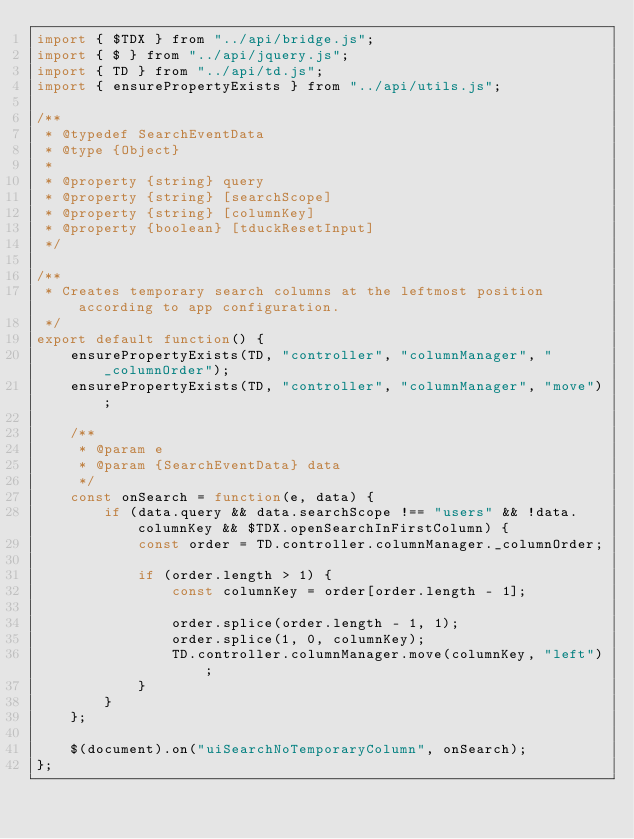Convert code to text. <code><loc_0><loc_0><loc_500><loc_500><_JavaScript_>import { $TDX } from "../api/bridge.js";
import { $ } from "../api/jquery.js";
import { TD } from "../api/td.js";
import { ensurePropertyExists } from "../api/utils.js";

/**
 * @typedef SearchEventData
 * @type {Object}
 *
 * @property {string} query
 * @property {string} [searchScope]
 * @property {string} [columnKey]
 * @property {boolean} [tduckResetInput]
 */

/**
 * Creates temporary search columns at the leftmost position according to app configuration.
 */
export default function() {
	ensurePropertyExists(TD, "controller", "columnManager", "_columnOrder");
	ensurePropertyExists(TD, "controller", "columnManager", "move");
	
	/**
	 * @param e
	 * @param {SearchEventData} data
	 */
	const onSearch = function(e, data) {
		if (data.query && data.searchScope !== "users" && !data.columnKey && $TDX.openSearchInFirstColumn) {
			const order = TD.controller.columnManager._columnOrder;
			
			if (order.length > 1) {
				const columnKey = order[order.length - 1];
				
				order.splice(order.length - 1, 1);
				order.splice(1, 0, columnKey);
				TD.controller.columnManager.move(columnKey, "left");
			}
		}
	};
	
	$(document).on("uiSearchNoTemporaryColumn", onSearch);
};
</code> 